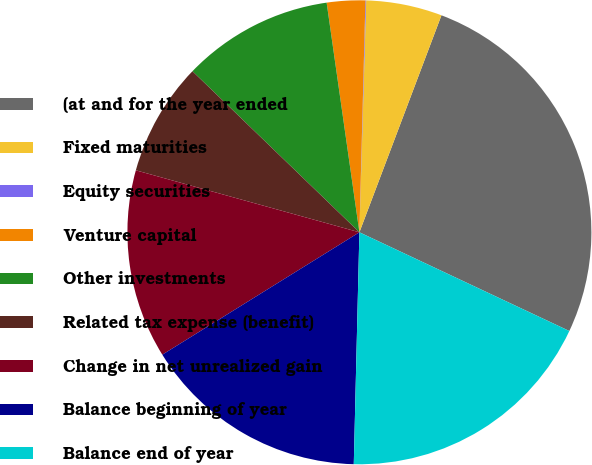Convert chart. <chart><loc_0><loc_0><loc_500><loc_500><pie_chart><fcel>(at and for the year ended<fcel>Fixed maturities<fcel>Equity securities<fcel>Venture capital<fcel>Other investments<fcel>Related tax expense (benefit)<fcel>Change in net unrealized gain<fcel>Balance beginning of year<fcel>Balance end of year<nl><fcel>26.24%<fcel>5.29%<fcel>0.05%<fcel>2.67%<fcel>10.53%<fcel>7.91%<fcel>13.15%<fcel>15.77%<fcel>18.39%<nl></chart> 